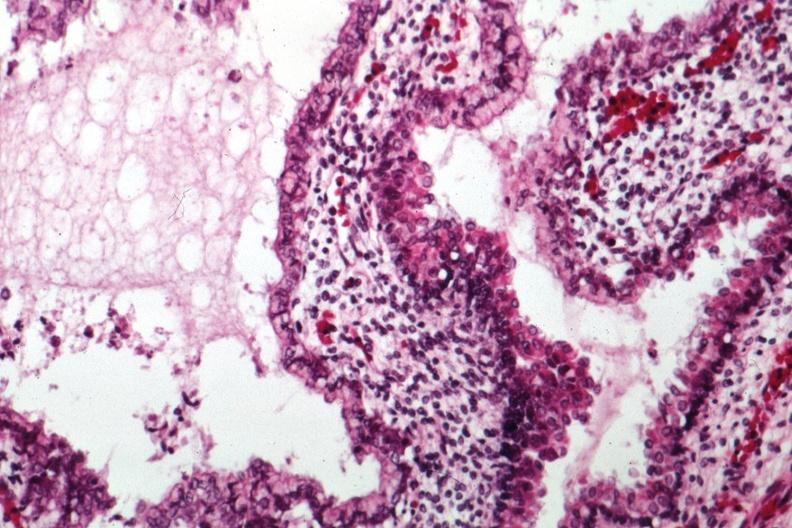what is present?
Answer the question using a single word or phrase. Sacrococcygeal teratoma 